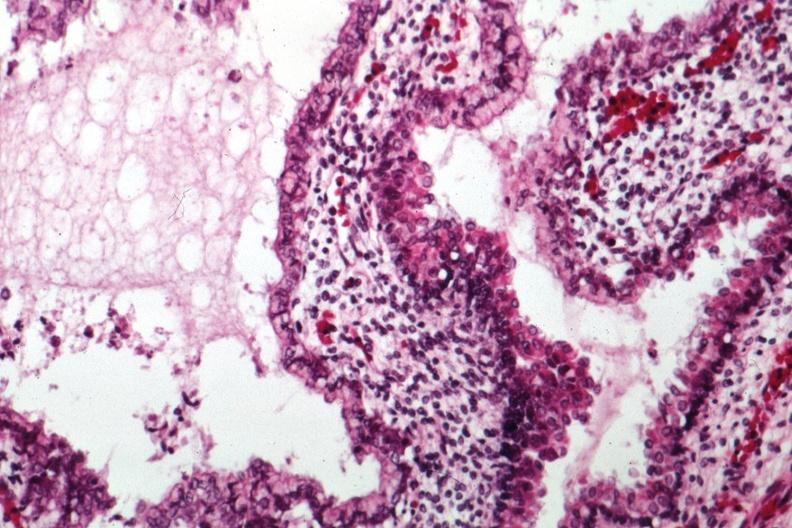what is present?
Answer the question using a single word or phrase. Sacrococcygeal teratoma 